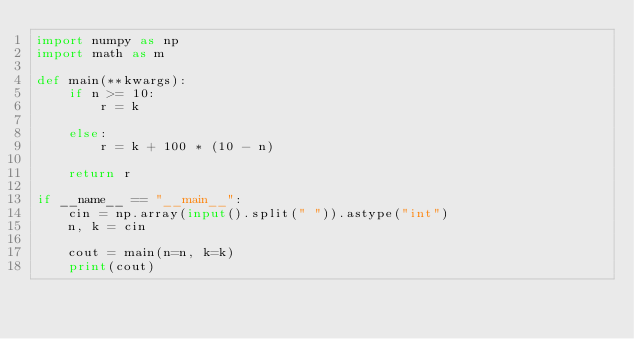<code> <loc_0><loc_0><loc_500><loc_500><_Python_>import numpy as np
import math as m

def main(**kwargs):
    if n >= 10:
        r = k

    else:
        r = k + 100 * (10 - n)

    return r

if __name__ == "__main__":
    cin = np.array(input().split(" ")).astype("int")
    n, k = cin

    cout = main(n=n, k=k)
    print(cout)</code> 